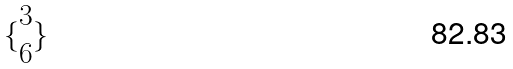<formula> <loc_0><loc_0><loc_500><loc_500>\{ \begin{matrix} 3 \\ 6 \end{matrix} \}</formula> 